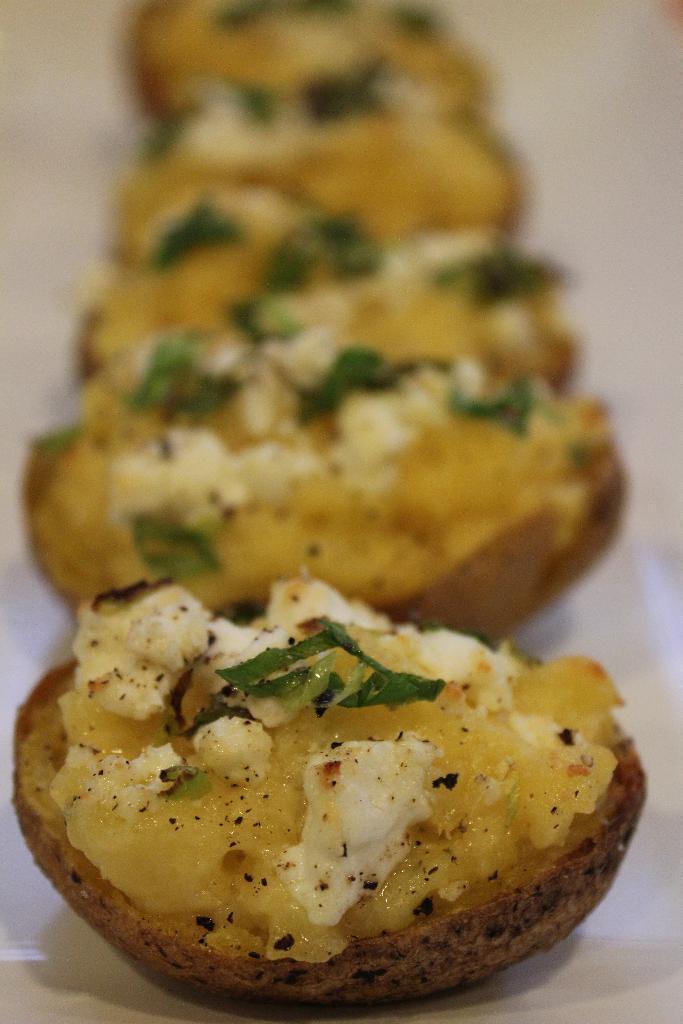Describe this image in one or two sentences. In this image there is food on the surface that looks like a table, the top of the image is blurred. 